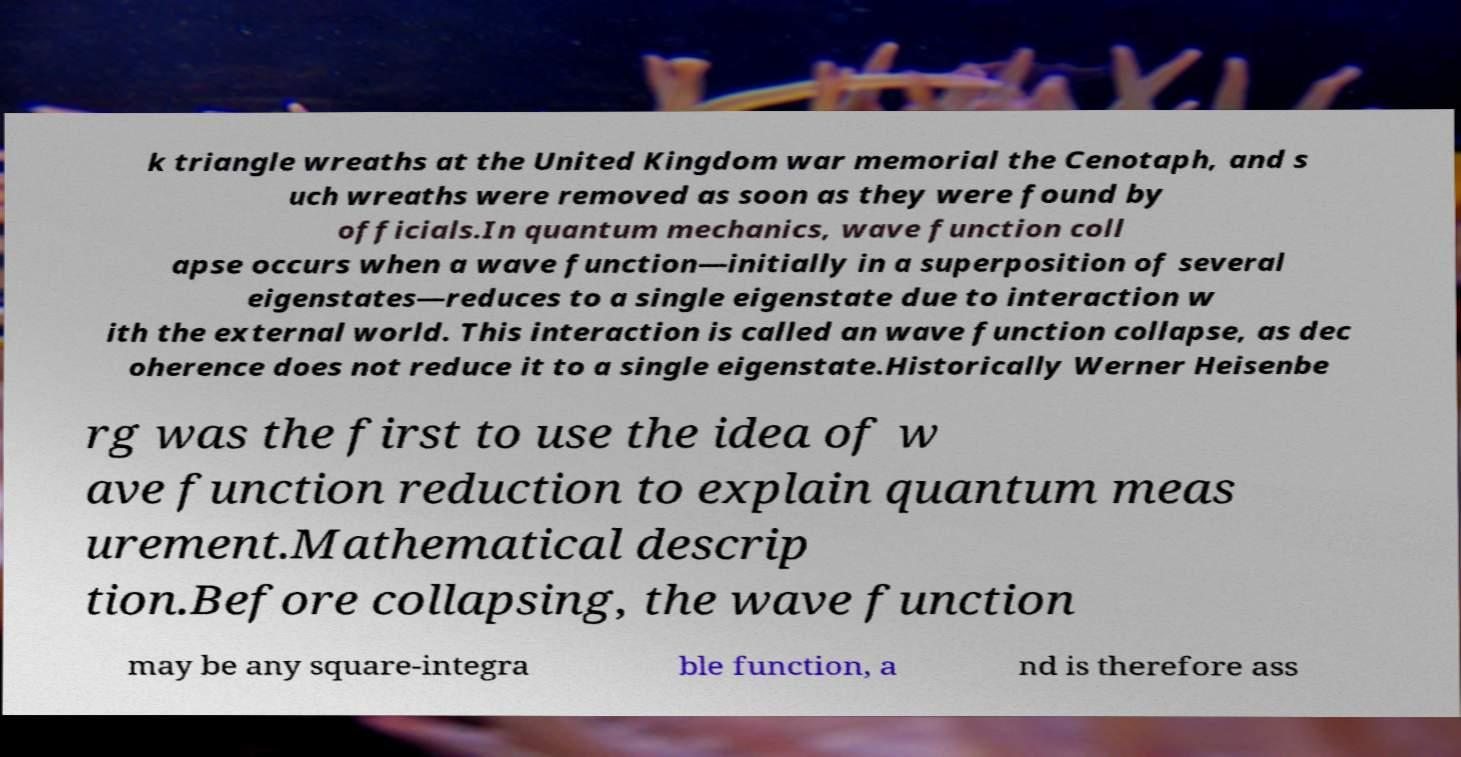Could you extract and type out the text from this image? k triangle wreaths at the United Kingdom war memorial the Cenotaph, and s uch wreaths were removed as soon as they were found by officials.In quantum mechanics, wave function coll apse occurs when a wave function—initially in a superposition of several eigenstates—reduces to a single eigenstate due to interaction w ith the external world. This interaction is called an wave function collapse, as dec oherence does not reduce it to a single eigenstate.Historically Werner Heisenbe rg was the first to use the idea of w ave function reduction to explain quantum meas urement.Mathematical descrip tion.Before collapsing, the wave function may be any square-integra ble function, a nd is therefore ass 